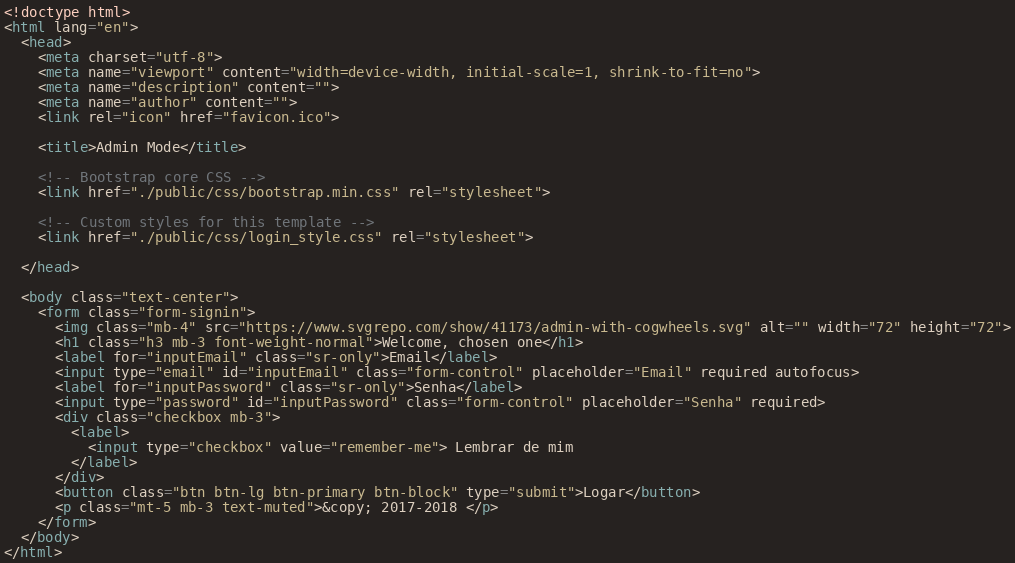<code> <loc_0><loc_0><loc_500><loc_500><_HTML_><!doctype html>
<html lang="en">
  <head>
    <meta charset="utf-8">
    <meta name="viewport" content="width=device-width, initial-scale=1, shrink-to-fit=no">
    <meta name="description" content="">
    <meta name="author" content="">
    <link rel="icon" href="favicon.ico">

    <title>Admin Mode</title>

    <!-- Bootstrap core CSS -->
    <link href="./public/css/bootstrap.min.css" rel="stylesheet">

    <!-- Custom styles for this template -->
    <link href="./public/css/login_style.css" rel="stylesheet">

  </head>

  <body class="text-center">
    <form class="form-signin">
      <img class="mb-4" src="https://www.svgrepo.com/show/41173/admin-with-cogwheels.svg" alt="" width="72" height="72">
      <h1 class="h3 mb-3 font-weight-normal">Welcome, chosen one</h1>
      <label for="inputEmail" class="sr-only">Email</label>
      <input type="email" id="inputEmail" class="form-control" placeholder="Email" required autofocus>
      <label for="inputPassword" class="sr-only">Senha</label>
      <input type="password" id="inputPassword" class="form-control" placeholder="Senha" required>
      <div class="checkbox mb-3">
        <label>
          <input type="checkbox" value="remember-me"> Lembrar de mim
        </label>
      </div>
      <button class="btn btn-lg btn-primary btn-block" type="submit">Logar</button>
      <p class="mt-5 mb-3 text-muted">&copy; 2017-2018 </p>
    </form>
  </body>
</html></code> 